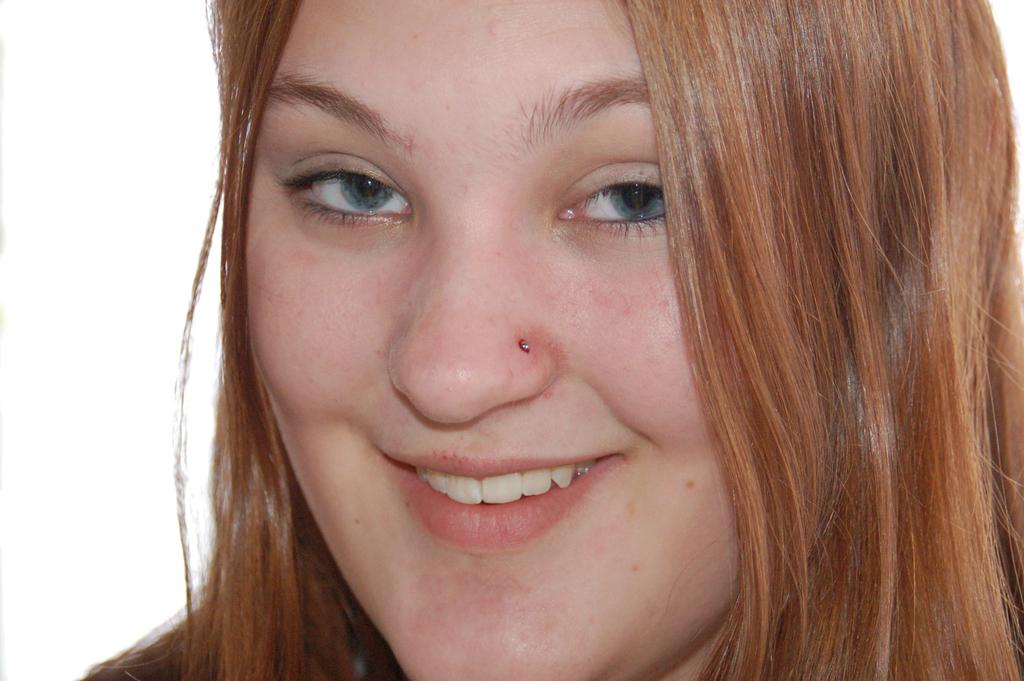Who is present in the image? There is a woman in the image. What is the woman doing in the image? The woman is smiling in the image. What color is the background of the image? The background of the image is white in color. What type of wire is the woman holding in the image? There is no wire present in the image; the woman is simply smiling. 